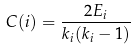<formula> <loc_0><loc_0><loc_500><loc_500>C ( i ) = \frac { 2 E _ { i } } { k _ { i } ( k _ { i } - 1 ) }</formula> 